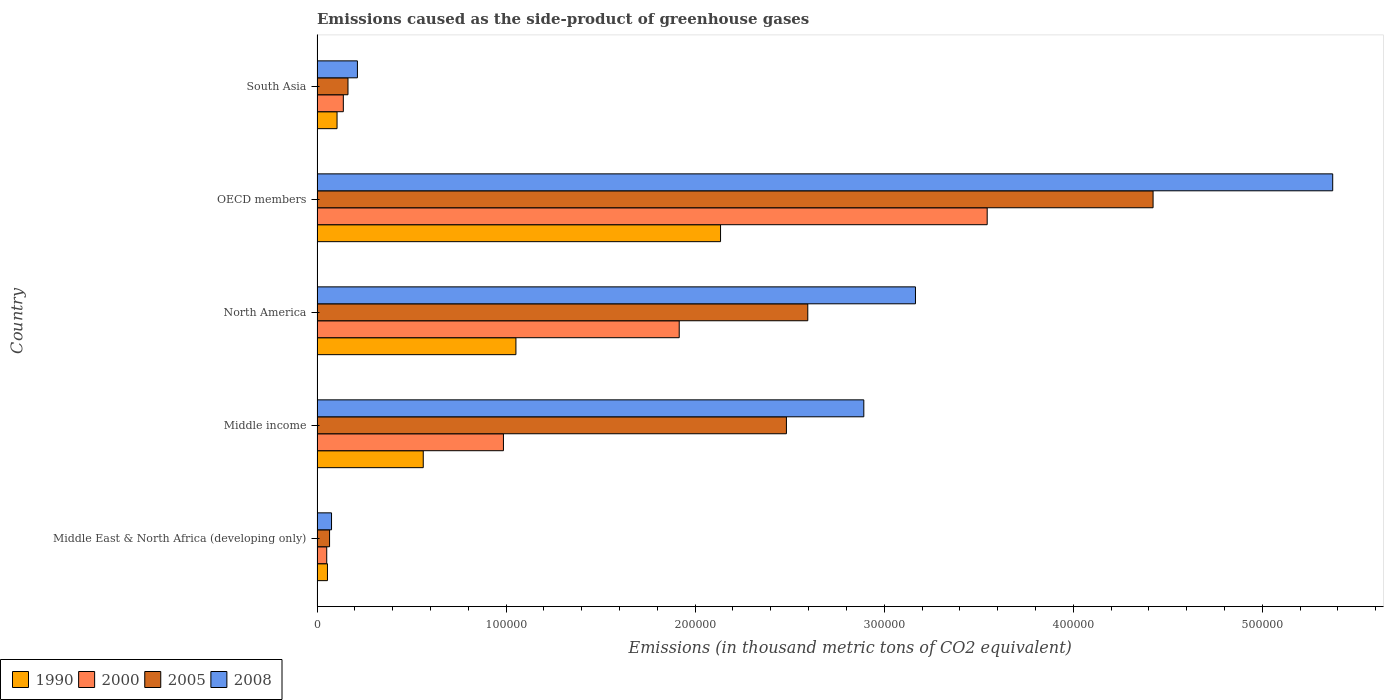How many groups of bars are there?
Your response must be concise. 5. Are the number of bars per tick equal to the number of legend labels?
Offer a very short reply. Yes. How many bars are there on the 1st tick from the top?
Provide a short and direct response. 4. In how many cases, is the number of bars for a given country not equal to the number of legend labels?
Keep it short and to the point. 0. What is the emissions caused as the side-product of greenhouse gases in 1990 in OECD members?
Provide a short and direct response. 2.13e+05. Across all countries, what is the maximum emissions caused as the side-product of greenhouse gases in 2005?
Your answer should be compact. 4.42e+05. Across all countries, what is the minimum emissions caused as the side-product of greenhouse gases in 2000?
Your answer should be compact. 5124.9. In which country was the emissions caused as the side-product of greenhouse gases in 2008 maximum?
Give a very brief answer. OECD members. In which country was the emissions caused as the side-product of greenhouse gases in 2008 minimum?
Ensure brevity in your answer.  Middle East & North Africa (developing only). What is the total emissions caused as the side-product of greenhouse gases in 2000 in the graph?
Provide a succinct answer. 6.64e+05. What is the difference between the emissions caused as the side-product of greenhouse gases in 2005 in OECD members and that in South Asia?
Make the answer very short. 4.26e+05. What is the difference between the emissions caused as the side-product of greenhouse gases in 2000 in OECD members and the emissions caused as the side-product of greenhouse gases in 2005 in Middle income?
Your answer should be very brief. 1.06e+05. What is the average emissions caused as the side-product of greenhouse gases in 2008 per country?
Provide a short and direct response. 2.34e+05. What is the difference between the emissions caused as the side-product of greenhouse gases in 1990 and emissions caused as the side-product of greenhouse gases in 2005 in Middle income?
Your answer should be compact. -1.92e+05. What is the ratio of the emissions caused as the side-product of greenhouse gases in 2005 in Middle East & North Africa (developing only) to that in Middle income?
Your answer should be very brief. 0.03. Is the difference between the emissions caused as the side-product of greenhouse gases in 1990 in Middle East & North Africa (developing only) and South Asia greater than the difference between the emissions caused as the side-product of greenhouse gases in 2005 in Middle East & North Africa (developing only) and South Asia?
Make the answer very short. Yes. What is the difference between the highest and the second highest emissions caused as the side-product of greenhouse gases in 2008?
Offer a very short reply. 2.21e+05. What is the difference between the highest and the lowest emissions caused as the side-product of greenhouse gases in 2000?
Provide a short and direct response. 3.49e+05. Is it the case that in every country, the sum of the emissions caused as the side-product of greenhouse gases in 2005 and emissions caused as the side-product of greenhouse gases in 2008 is greater than the sum of emissions caused as the side-product of greenhouse gases in 1990 and emissions caused as the side-product of greenhouse gases in 2000?
Your response must be concise. No. What does the 3rd bar from the top in South Asia represents?
Give a very brief answer. 2000. How many bars are there?
Provide a short and direct response. 20. How many countries are there in the graph?
Provide a succinct answer. 5. What is the difference between two consecutive major ticks on the X-axis?
Your response must be concise. 1.00e+05. Are the values on the major ticks of X-axis written in scientific E-notation?
Offer a very short reply. No. Does the graph contain any zero values?
Give a very brief answer. No. Does the graph contain grids?
Your answer should be very brief. No. How are the legend labels stacked?
Keep it short and to the point. Horizontal. What is the title of the graph?
Your answer should be very brief. Emissions caused as the side-product of greenhouse gases. Does "1971" appear as one of the legend labels in the graph?
Your answer should be compact. No. What is the label or title of the X-axis?
Give a very brief answer. Emissions (in thousand metric tons of CO2 equivalent). What is the Emissions (in thousand metric tons of CO2 equivalent) in 1990 in Middle East & North Africa (developing only)?
Ensure brevity in your answer.  5502.6. What is the Emissions (in thousand metric tons of CO2 equivalent) in 2000 in Middle East & North Africa (developing only)?
Ensure brevity in your answer.  5124.9. What is the Emissions (in thousand metric tons of CO2 equivalent) in 2005 in Middle East & North Africa (developing only)?
Keep it short and to the point. 6617.8. What is the Emissions (in thousand metric tons of CO2 equivalent) in 2008 in Middle East & North Africa (developing only)?
Your answer should be very brief. 7657.2. What is the Emissions (in thousand metric tons of CO2 equivalent) of 1990 in Middle income?
Give a very brief answer. 5.62e+04. What is the Emissions (in thousand metric tons of CO2 equivalent) in 2000 in Middle income?
Provide a succinct answer. 9.86e+04. What is the Emissions (in thousand metric tons of CO2 equivalent) of 2005 in Middle income?
Make the answer very short. 2.48e+05. What is the Emissions (in thousand metric tons of CO2 equivalent) in 2008 in Middle income?
Give a very brief answer. 2.89e+05. What is the Emissions (in thousand metric tons of CO2 equivalent) in 1990 in North America?
Your answer should be very brief. 1.05e+05. What is the Emissions (in thousand metric tons of CO2 equivalent) of 2000 in North America?
Your response must be concise. 1.92e+05. What is the Emissions (in thousand metric tons of CO2 equivalent) of 2005 in North America?
Offer a very short reply. 2.60e+05. What is the Emissions (in thousand metric tons of CO2 equivalent) in 2008 in North America?
Provide a succinct answer. 3.17e+05. What is the Emissions (in thousand metric tons of CO2 equivalent) in 1990 in OECD members?
Offer a very short reply. 2.13e+05. What is the Emissions (in thousand metric tons of CO2 equivalent) of 2000 in OECD members?
Your answer should be compact. 3.54e+05. What is the Emissions (in thousand metric tons of CO2 equivalent) in 2005 in OECD members?
Ensure brevity in your answer.  4.42e+05. What is the Emissions (in thousand metric tons of CO2 equivalent) of 2008 in OECD members?
Provide a succinct answer. 5.37e+05. What is the Emissions (in thousand metric tons of CO2 equivalent) of 1990 in South Asia?
Your answer should be compact. 1.06e+04. What is the Emissions (in thousand metric tons of CO2 equivalent) in 2000 in South Asia?
Provide a short and direct response. 1.39e+04. What is the Emissions (in thousand metric tons of CO2 equivalent) in 2005 in South Asia?
Offer a terse response. 1.64e+04. What is the Emissions (in thousand metric tons of CO2 equivalent) in 2008 in South Asia?
Give a very brief answer. 2.14e+04. Across all countries, what is the maximum Emissions (in thousand metric tons of CO2 equivalent) of 1990?
Offer a terse response. 2.13e+05. Across all countries, what is the maximum Emissions (in thousand metric tons of CO2 equivalent) of 2000?
Offer a terse response. 3.54e+05. Across all countries, what is the maximum Emissions (in thousand metric tons of CO2 equivalent) of 2005?
Provide a succinct answer. 4.42e+05. Across all countries, what is the maximum Emissions (in thousand metric tons of CO2 equivalent) of 2008?
Give a very brief answer. 5.37e+05. Across all countries, what is the minimum Emissions (in thousand metric tons of CO2 equivalent) in 1990?
Your response must be concise. 5502.6. Across all countries, what is the minimum Emissions (in thousand metric tons of CO2 equivalent) of 2000?
Give a very brief answer. 5124.9. Across all countries, what is the minimum Emissions (in thousand metric tons of CO2 equivalent) of 2005?
Offer a very short reply. 6617.8. Across all countries, what is the minimum Emissions (in thousand metric tons of CO2 equivalent) of 2008?
Your response must be concise. 7657.2. What is the total Emissions (in thousand metric tons of CO2 equivalent) in 1990 in the graph?
Provide a short and direct response. 3.91e+05. What is the total Emissions (in thousand metric tons of CO2 equivalent) of 2000 in the graph?
Ensure brevity in your answer.  6.64e+05. What is the total Emissions (in thousand metric tons of CO2 equivalent) in 2005 in the graph?
Provide a succinct answer. 9.73e+05. What is the total Emissions (in thousand metric tons of CO2 equivalent) in 2008 in the graph?
Ensure brevity in your answer.  1.17e+06. What is the difference between the Emissions (in thousand metric tons of CO2 equivalent) in 1990 in Middle East & North Africa (developing only) and that in Middle income?
Give a very brief answer. -5.07e+04. What is the difference between the Emissions (in thousand metric tons of CO2 equivalent) in 2000 in Middle East & North Africa (developing only) and that in Middle income?
Your response must be concise. -9.35e+04. What is the difference between the Emissions (in thousand metric tons of CO2 equivalent) in 2005 in Middle East & North Africa (developing only) and that in Middle income?
Provide a succinct answer. -2.42e+05. What is the difference between the Emissions (in thousand metric tons of CO2 equivalent) of 2008 in Middle East & North Africa (developing only) and that in Middle income?
Provide a succinct answer. -2.82e+05. What is the difference between the Emissions (in thousand metric tons of CO2 equivalent) in 1990 in Middle East & North Africa (developing only) and that in North America?
Provide a short and direct response. -9.97e+04. What is the difference between the Emissions (in thousand metric tons of CO2 equivalent) of 2000 in Middle East & North Africa (developing only) and that in North America?
Make the answer very short. -1.86e+05. What is the difference between the Emissions (in thousand metric tons of CO2 equivalent) in 2005 in Middle East & North Africa (developing only) and that in North America?
Ensure brevity in your answer.  -2.53e+05. What is the difference between the Emissions (in thousand metric tons of CO2 equivalent) of 2008 in Middle East & North Africa (developing only) and that in North America?
Provide a short and direct response. -3.09e+05. What is the difference between the Emissions (in thousand metric tons of CO2 equivalent) of 1990 in Middle East & North Africa (developing only) and that in OECD members?
Offer a very short reply. -2.08e+05. What is the difference between the Emissions (in thousand metric tons of CO2 equivalent) in 2000 in Middle East & North Africa (developing only) and that in OECD members?
Keep it short and to the point. -3.49e+05. What is the difference between the Emissions (in thousand metric tons of CO2 equivalent) of 2005 in Middle East & North Africa (developing only) and that in OECD members?
Your response must be concise. -4.36e+05. What is the difference between the Emissions (in thousand metric tons of CO2 equivalent) of 2008 in Middle East & North Africa (developing only) and that in OECD members?
Keep it short and to the point. -5.30e+05. What is the difference between the Emissions (in thousand metric tons of CO2 equivalent) in 1990 in Middle East & North Africa (developing only) and that in South Asia?
Ensure brevity in your answer.  -5070. What is the difference between the Emissions (in thousand metric tons of CO2 equivalent) of 2000 in Middle East & North Africa (developing only) and that in South Asia?
Offer a very short reply. -8773. What is the difference between the Emissions (in thousand metric tons of CO2 equivalent) of 2005 in Middle East & North Africa (developing only) and that in South Asia?
Make the answer very short. -9741.3. What is the difference between the Emissions (in thousand metric tons of CO2 equivalent) of 2008 in Middle East & North Africa (developing only) and that in South Asia?
Give a very brief answer. -1.37e+04. What is the difference between the Emissions (in thousand metric tons of CO2 equivalent) of 1990 in Middle income and that in North America?
Provide a short and direct response. -4.90e+04. What is the difference between the Emissions (in thousand metric tons of CO2 equivalent) in 2000 in Middle income and that in North America?
Give a very brief answer. -9.30e+04. What is the difference between the Emissions (in thousand metric tons of CO2 equivalent) in 2005 in Middle income and that in North America?
Ensure brevity in your answer.  -1.13e+04. What is the difference between the Emissions (in thousand metric tons of CO2 equivalent) of 2008 in Middle income and that in North America?
Provide a succinct answer. -2.73e+04. What is the difference between the Emissions (in thousand metric tons of CO2 equivalent) of 1990 in Middle income and that in OECD members?
Your response must be concise. -1.57e+05. What is the difference between the Emissions (in thousand metric tons of CO2 equivalent) of 2000 in Middle income and that in OECD members?
Your answer should be compact. -2.56e+05. What is the difference between the Emissions (in thousand metric tons of CO2 equivalent) in 2005 in Middle income and that in OECD members?
Offer a terse response. -1.94e+05. What is the difference between the Emissions (in thousand metric tons of CO2 equivalent) of 2008 in Middle income and that in OECD members?
Your answer should be very brief. -2.48e+05. What is the difference between the Emissions (in thousand metric tons of CO2 equivalent) of 1990 in Middle income and that in South Asia?
Offer a terse response. 4.56e+04. What is the difference between the Emissions (in thousand metric tons of CO2 equivalent) of 2000 in Middle income and that in South Asia?
Make the answer very short. 8.47e+04. What is the difference between the Emissions (in thousand metric tons of CO2 equivalent) in 2005 in Middle income and that in South Asia?
Make the answer very short. 2.32e+05. What is the difference between the Emissions (in thousand metric tons of CO2 equivalent) of 2008 in Middle income and that in South Asia?
Offer a terse response. 2.68e+05. What is the difference between the Emissions (in thousand metric tons of CO2 equivalent) of 1990 in North America and that in OECD members?
Ensure brevity in your answer.  -1.08e+05. What is the difference between the Emissions (in thousand metric tons of CO2 equivalent) in 2000 in North America and that in OECD members?
Ensure brevity in your answer.  -1.63e+05. What is the difference between the Emissions (in thousand metric tons of CO2 equivalent) of 2005 in North America and that in OECD members?
Offer a terse response. -1.83e+05. What is the difference between the Emissions (in thousand metric tons of CO2 equivalent) of 2008 in North America and that in OECD members?
Ensure brevity in your answer.  -2.21e+05. What is the difference between the Emissions (in thousand metric tons of CO2 equivalent) in 1990 in North America and that in South Asia?
Offer a terse response. 9.46e+04. What is the difference between the Emissions (in thousand metric tons of CO2 equivalent) in 2000 in North America and that in South Asia?
Make the answer very short. 1.78e+05. What is the difference between the Emissions (in thousand metric tons of CO2 equivalent) of 2005 in North America and that in South Asia?
Offer a terse response. 2.43e+05. What is the difference between the Emissions (in thousand metric tons of CO2 equivalent) of 2008 in North America and that in South Asia?
Your answer should be compact. 2.95e+05. What is the difference between the Emissions (in thousand metric tons of CO2 equivalent) of 1990 in OECD members and that in South Asia?
Your answer should be compact. 2.03e+05. What is the difference between the Emissions (in thousand metric tons of CO2 equivalent) of 2000 in OECD members and that in South Asia?
Keep it short and to the point. 3.41e+05. What is the difference between the Emissions (in thousand metric tons of CO2 equivalent) in 2005 in OECD members and that in South Asia?
Give a very brief answer. 4.26e+05. What is the difference between the Emissions (in thousand metric tons of CO2 equivalent) in 2008 in OECD members and that in South Asia?
Offer a very short reply. 5.16e+05. What is the difference between the Emissions (in thousand metric tons of CO2 equivalent) of 1990 in Middle East & North Africa (developing only) and the Emissions (in thousand metric tons of CO2 equivalent) of 2000 in Middle income?
Give a very brief answer. -9.31e+04. What is the difference between the Emissions (in thousand metric tons of CO2 equivalent) of 1990 in Middle East & North Africa (developing only) and the Emissions (in thousand metric tons of CO2 equivalent) of 2005 in Middle income?
Your answer should be very brief. -2.43e+05. What is the difference between the Emissions (in thousand metric tons of CO2 equivalent) in 1990 in Middle East & North Africa (developing only) and the Emissions (in thousand metric tons of CO2 equivalent) in 2008 in Middle income?
Ensure brevity in your answer.  -2.84e+05. What is the difference between the Emissions (in thousand metric tons of CO2 equivalent) of 2000 in Middle East & North Africa (developing only) and the Emissions (in thousand metric tons of CO2 equivalent) of 2005 in Middle income?
Ensure brevity in your answer.  -2.43e+05. What is the difference between the Emissions (in thousand metric tons of CO2 equivalent) in 2000 in Middle East & North Africa (developing only) and the Emissions (in thousand metric tons of CO2 equivalent) in 2008 in Middle income?
Make the answer very short. -2.84e+05. What is the difference between the Emissions (in thousand metric tons of CO2 equivalent) of 2005 in Middle East & North Africa (developing only) and the Emissions (in thousand metric tons of CO2 equivalent) of 2008 in Middle income?
Your answer should be very brief. -2.83e+05. What is the difference between the Emissions (in thousand metric tons of CO2 equivalent) of 1990 in Middle East & North Africa (developing only) and the Emissions (in thousand metric tons of CO2 equivalent) of 2000 in North America?
Give a very brief answer. -1.86e+05. What is the difference between the Emissions (in thousand metric tons of CO2 equivalent) of 1990 in Middle East & North Africa (developing only) and the Emissions (in thousand metric tons of CO2 equivalent) of 2005 in North America?
Ensure brevity in your answer.  -2.54e+05. What is the difference between the Emissions (in thousand metric tons of CO2 equivalent) in 1990 in Middle East & North Africa (developing only) and the Emissions (in thousand metric tons of CO2 equivalent) in 2008 in North America?
Offer a terse response. -3.11e+05. What is the difference between the Emissions (in thousand metric tons of CO2 equivalent) in 2000 in Middle East & North Africa (developing only) and the Emissions (in thousand metric tons of CO2 equivalent) in 2005 in North America?
Your response must be concise. -2.54e+05. What is the difference between the Emissions (in thousand metric tons of CO2 equivalent) in 2000 in Middle East & North Africa (developing only) and the Emissions (in thousand metric tons of CO2 equivalent) in 2008 in North America?
Offer a terse response. -3.11e+05. What is the difference between the Emissions (in thousand metric tons of CO2 equivalent) of 2005 in Middle East & North Africa (developing only) and the Emissions (in thousand metric tons of CO2 equivalent) of 2008 in North America?
Your answer should be compact. -3.10e+05. What is the difference between the Emissions (in thousand metric tons of CO2 equivalent) of 1990 in Middle East & North Africa (developing only) and the Emissions (in thousand metric tons of CO2 equivalent) of 2000 in OECD members?
Your answer should be very brief. -3.49e+05. What is the difference between the Emissions (in thousand metric tons of CO2 equivalent) in 1990 in Middle East & North Africa (developing only) and the Emissions (in thousand metric tons of CO2 equivalent) in 2005 in OECD members?
Your answer should be compact. -4.37e+05. What is the difference between the Emissions (in thousand metric tons of CO2 equivalent) in 1990 in Middle East & North Africa (developing only) and the Emissions (in thousand metric tons of CO2 equivalent) in 2008 in OECD members?
Your answer should be compact. -5.32e+05. What is the difference between the Emissions (in thousand metric tons of CO2 equivalent) of 2000 in Middle East & North Africa (developing only) and the Emissions (in thousand metric tons of CO2 equivalent) of 2005 in OECD members?
Provide a succinct answer. -4.37e+05. What is the difference between the Emissions (in thousand metric tons of CO2 equivalent) of 2000 in Middle East & North Africa (developing only) and the Emissions (in thousand metric tons of CO2 equivalent) of 2008 in OECD members?
Provide a succinct answer. -5.32e+05. What is the difference between the Emissions (in thousand metric tons of CO2 equivalent) of 2005 in Middle East & North Africa (developing only) and the Emissions (in thousand metric tons of CO2 equivalent) of 2008 in OECD members?
Provide a succinct answer. -5.31e+05. What is the difference between the Emissions (in thousand metric tons of CO2 equivalent) of 1990 in Middle East & North Africa (developing only) and the Emissions (in thousand metric tons of CO2 equivalent) of 2000 in South Asia?
Provide a succinct answer. -8395.3. What is the difference between the Emissions (in thousand metric tons of CO2 equivalent) of 1990 in Middle East & North Africa (developing only) and the Emissions (in thousand metric tons of CO2 equivalent) of 2005 in South Asia?
Make the answer very short. -1.09e+04. What is the difference between the Emissions (in thousand metric tons of CO2 equivalent) of 1990 in Middle East & North Africa (developing only) and the Emissions (in thousand metric tons of CO2 equivalent) of 2008 in South Asia?
Provide a succinct answer. -1.59e+04. What is the difference between the Emissions (in thousand metric tons of CO2 equivalent) in 2000 in Middle East & North Africa (developing only) and the Emissions (in thousand metric tons of CO2 equivalent) in 2005 in South Asia?
Provide a short and direct response. -1.12e+04. What is the difference between the Emissions (in thousand metric tons of CO2 equivalent) in 2000 in Middle East & North Africa (developing only) and the Emissions (in thousand metric tons of CO2 equivalent) in 2008 in South Asia?
Your response must be concise. -1.62e+04. What is the difference between the Emissions (in thousand metric tons of CO2 equivalent) in 2005 in Middle East & North Africa (developing only) and the Emissions (in thousand metric tons of CO2 equivalent) in 2008 in South Asia?
Your answer should be very brief. -1.47e+04. What is the difference between the Emissions (in thousand metric tons of CO2 equivalent) in 1990 in Middle income and the Emissions (in thousand metric tons of CO2 equivalent) in 2000 in North America?
Give a very brief answer. -1.35e+05. What is the difference between the Emissions (in thousand metric tons of CO2 equivalent) of 1990 in Middle income and the Emissions (in thousand metric tons of CO2 equivalent) of 2005 in North America?
Provide a short and direct response. -2.03e+05. What is the difference between the Emissions (in thousand metric tons of CO2 equivalent) of 1990 in Middle income and the Emissions (in thousand metric tons of CO2 equivalent) of 2008 in North America?
Your response must be concise. -2.60e+05. What is the difference between the Emissions (in thousand metric tons of CO2 equivalent) in 2000 in Middle income and the Emissions (in thousand metric tons of CO2 equivalent) in 2005 in North America?
Provide a succinct answer. -1.61e+05. What is the difference between the Emissions (in thousand metric tons of CO2 equivalent) of 2000 in Middle income and the Emissions (in thousand metric tons of CO2 equivalent) of 2008 in North America?
Keep it short and to the point. -2.18e+05. What is the difference between the Emissions (in thousand metric tons of CO2 equivalent) in 2005 in Middle income and the Emissions (in thousand metric tons of CO2 equivalent) in 2008 in North America?
Provide a succinct answer. -6.83e+04. What is the difference between the Emissions (in thousand metric tons of CO2 equivalent) in 1990 in Middle income and the Emissions (in thousand metric tons of CO2 equivalent) in 2000 in OECD members?
Offer a very short reply. -2.98e+05. What is the difference between the Emissions (in thousand metric tons of CO2 equivalent) in 1990 in Middle income and the Emissions (in thousand metric tons of CO2 equivalent) in 2005 in OECD members?
Make the answer very short. -3.86e+05. What is the difference between the Emissions (in thousand metric tons of CO2 equivalent) of 1990 in Middle income and the Emissions (in thousand metric tons of CO2 equivalent) of 2008 in OECD members?
Provide a short and direct response. -4.81e+05. What is the difference between the Emissions (in thousand metric tons of CO2 equivalent) in 2000 in Middle income and the Emissions (in thousand metric tons of CO2 equivalent) in 2005 in OECD members?
Offer a very short reply. -3.44e+05. What is the difference between the Emissions (in thousand metric tons of CO2 equivalent) in 2000 in Middle income and the Emissions (in thousand metric tons of CO2 equivalent) in 2008 in OECD members?
Ensure brevity in your answer.  -4.39e+05. What is the difference between the Emissions (in thousand metric tons of CO2 equivalent) of 2005 in Middle income and the Emissions (in thousand metric tons of CO2 equivalent) of 2008 in OECD members?
Your answer should be compact. -2.89e+05. What is the difference between the Emissions (in thousand metric tons of CO2 equivalent) in 1990 in Middle income and the Emissions (in thousand metric tons of CO2 equivalent) in 2000 in South Asia?
Your response must be concise. 4.23e+04. What is the difference between the Emissions (in thousand metric tons of CO2 equivalent) in 1990 in Middle income and the Emissions (in thousand metric tons of CO2 equivalent) in 2005 in South Asia?
Keep it short and to the point. 3.98e+04. What is the difference between the Emissions (in thousand metric tons of CO2 equivalent) in 1990 in Middle income and the Emissions (in thousand metric tons of CO2 equivalent) in 2008 in South Asia?
Make the answer very short. 3.48e+04. What is the difference between the Emissions (in thousand metric tons of CO2 equivalent) in 2000 in Middle income and the Emissions (in thousand metric tons of CO2 equivalent) in 2005 in South Asia?
Your response must be concise. 8.22e+04. What is the difference between the Emissions (in thousand metric tons of CO2 equivalent) of 2000 in Middle income and the Emissions (in thousand metric tons of CO2 equivalent) of 2008 in South Asia?
Offer a terse response. 7.72e+04. What is the difference between the Emissions (in thousand metric tons of CO2 equivalent) of 2005 in Middle income and the Emissions (in thousand metric tons of CO2 equivalent) of 2008 in South Asia?
Provide a succinct answer. 2.27e+05. What is the difference between the Emissions (in thousand metric tons of CO2 equivalent) of 1990 in North America and the Emissions (in thousand metric tons of CO2 equivalent) of 2000 in OECD members?
Your answer should be compact. -2.49e+05. What is the difference between the Emissions (in thousand metric tons of CO2 equivalent) of 1990 in North America and the Emissions (in thousand metric tons of CO2 equivalent) of 2005 in OECD members?
Offer a terse response. -3.37e+05. What is the difference between the Emissions (in thousand metric tons of CO2 equivalent) of 1990 in North America and the Emissions (in thousand metric tons of CO2 equivalent) of 2008 in OECD members?
Give a very brief answer. -4.32e+05. What is the difference between the Emissions (in thousand metric tons of CO2 equivalent) of 2000 in North America and the Emissions (in thousand metric tons of CO2 equivalent) of 2005 in OECD members?
Make the answer very short. -2.51e+05. What is the difference between the Emissions (in thousand metric tons of CO2 equivalent) of 2000 in North America and the Emissions (in thousand metric tons of CO2 equivalent) of 2008 in OECD members?
Give a very brief answer. -3.46e+05. What is the difference between the Emissions (in thousand metric tons of CO2 equivalent) of 2005 in North America and the Emissions (in thousand metric tons of CO2 equivalent) of 2008 in OECD members?
Keep it short and to the point. -2.78e+05. What is the difference between the Emissions (in thousand metric tons of CO2 equivalent) in 1990 in North America and the Emissions (in thousand metric tons of CO2 equivalent) in 2000 in South Asia?
Provide a short and direct response. 9.13e+04. What is the difference between the Emissions (in thousand metric tons of CO2 equivalent) in 1990 in North America and the Emissions (in thousand metric tons of CO2 equivalent) in 2005 in South Asia?
Offer a terse response. 8.88e+04. What is the difference between the Emissions (in thousand metric tons of CO2 equivalent) of 1990 in North America and the Emissions (in thousand metric tons of CO2 equivalent) of 2008 in South Asia?
Your answer should be very brief. 8.38e+04. What is the difference between the Emissions (in thousand metric tons of CO2 equivalent) in 2000 in North America and the Emissions (in thousand metric tons of CO2 equivalent) in 2005 in South Asia?
Keep it short and to the point. 1.75e+05. What is the difference between the Emissions (in thousand metric tons of CO2 equivalent) in 2000 in North America and the Emissions (in thousand metric tons of CO2 equivalent) in 2008 in South Asia?
Your response must be concise. 1.70e+05. What is the difference between the Emissions (in thousand metric tons of CO2 equivalent) in 2005 in North America and the Emissions (in thousand metric tons of CO2 equivalent) in 2008 in South Asia?
Make the answer very short. 2.38e+05. What is the difference between the Emissions (in thousand metric tons of CO2 equivalent) in 1990 in OECD members and the Emissions (in thousand metric tons of CO2 equivalent) in 2000 in South Asia?
Give a very brief answer. 2.00e+05. What is the difference between the Emissions (in thousand metric tons of CO2 equivalent) of 1990 in OECD members and the Emissions (in thousand metric tons of CO2 equivalent) of 2005 in South Asia?
Your response must be concise. 1.97e+05. What is the difference between the Emissions (in thousand metric tons of CO2 equivalent) of 1990 in OECD members and the Emissions (in thousand metric tons of CO2 equivalent) of 2008 in South Asia?
Make the answer very short. 1.92e+05. What is the difference between the Emissions (in thousand metric tons of CO2 equivalent) of 2000 in OECD members and the Emissions (in thousand metric tons of CO2 equivalent) of 2005 in South Asia?
Your response must be concise. 3.38e+05. What is the difference between the Emissions (in thousand metric tons of CO2 equivalent) in 2000 in OECD members and the Emissions (in thousand metric tons of CO2 equivalent) in 2008 in South Asia?
Give a very brief answer. 3.33e+05. What is the difference between the Emissions (in thousand metric tons of CO2 equivalent) of 2005 in OECD members and the Emissions (in thousand metric tons of CO2 equivalent) of 2008 in South Asia?
Offer a terse response. 4.21e+05. What is the average Emissions (in thousand metric tons of CO2 equivalent) of 1990 per country?
Provide a short and direct response. 7.82e+04. What is the average Emissions (in thousand metric tons of CO2 equivalent) in 2000 per country?
Provide a succinct answer. 1.33e+05. What is the average Emissions (in thousand metric tons of CO2 equivalent) in 2005 per country?
Make the answer very short. 1.95e+05. What is the average Emissions (in thousand metric tons of CO2 equivalent) in 2008 per country?
Your answer should be very brief. 2.34e+05. What is the difference between the Emissions (in thousand metric tons of CO2 equivalent) of 1990 and Emissions (in thousand metric tons of CO2 equivalent) of 2000 in Middle East & North Africa (developing only)?
Ensure brevity in your answer.  377.7. What is the difference between the Emissions (in thousand metric tons of CO2 equivalent) of 1990 and Emissions (in thousand metric tons of CO2 equivalent) of 2005 in Middle East & North Africa (developing only)?
Provide a short and direct response. -1115.2. What is the difference between the Emissions (in thousand metric tons of CO2 equivalent) in 1990 and Emissions (in thousand metric tons of CO2 equivalent) in 2008 in Middle East & North Africa (developing only)?
Offer a terse response. -2154.6. What is the difference between the Emissions (in thousand metric tons of CO2 equivalent) in 2000 and Emissions (in thousand metric tons of CO2 equivalent) in 2005 in Middle East & North Africa (developing only)?
Your answer should be compact. -1492.9. What is the difference between the Emissions (in thousand metric tons of CO2 equivalent) in 2000 and Emissions (in thousand metric tons of CO2 equivalent) in 2008 in Middle East & North Africa (developing only)?
Offer a very short reply. -2532.3. What is the difference between the Emissions (in thousand metric tons of CO2 equivalent) in 2005 and Emissions (in thousand metric tons of CO2 equivalent) in 2008 in Middle East & North Africa (developing only)?
Provide a short and direct response. -1039.4. What is the difference between the Emissions (in thousand metric tons of CO2 equivalent) in 1990 and Emissions (in thousand metric tons of CO2 equivalent) in 2000 in Middle income?
Offer a terse response. -4.24e+04. What is the difference between the Emissions (in thousand metric tons of CO2 equivalent) in 1990 and Emissions (in thousand metric tons of CO2 equivalent) in 2005 in Middle income?
Offer a very short reply. -1.92e+05. What is the difference between the Emissions (in thousand metric tons of CO2 equivalent) in 1990 and Emissions (in thousand metric tons of CO2 equivalent) in 2008 in Middle income?
Keep it short and to the point. -2.33e+05. What is the difference between the Emissions (in thousand metric tons of CO2 equivalent) in 2000 and Emissions (in thousand metric tons of CO2 equivalent) in 2005 in Middle income?
Give a very brief answer. -1.50e+05. What is the difference between the Emissions (in thousand metric tons of CO2 equivalent) of 2000 and Emissions (in thousand metric tons of CO2 equivalent) of 2008 in Middle income?
Make the answer very short. -1.91e+05. What is the difference between the Emissions (in thousand metric tons of CO2 equivalent) in 2005 and Emissions (in thousand metric tons of CO2 equivalent) in 2008 in Middle income?
Ensure brevity in your answer.  -4.09e+04. What is the difference between the Emissions (in thousand metric tons of CO2 equivalent) of 1990 and Emissions (in thousand metric tons of CO2 equivalent) of 2000 in North America?
Your answer should be compact. -8.64e+04. What is the difference between the Emissions (in thousand metric tons of CO2 equivalent) in 1990 and Emissions (in thousand metric tons of CO2 equivalent) in 2005 in North America?
Provide a succinct answer. -1.54e+05. What is the difference between the Emissions (in thousand metric tons of CO2 equivalent) in 1990 and Emissions (in thousand metric tons of CO2 equivalent) in 2008 in North America?
Ensure brevity in your answer.  -2.11e+05. What is the difference between the Emissions (in thousand metric tons of CO2 equivalent) of 2000 and Emissions (in thousand metric tons of CO2 equivalent) of 2005 in North America?
Offer a very short reply. -6.80e+04. What is the difference between the Emissions (in thousand metric tons of CO2 equivalent) in 2000 and Emissions (in thousand metric tons of CO2 equivalent) in 2008 in North America?
Ensure brevity in your answer.  -1.25e+05. What is the difference between the Emissions (in thousand metric tons of CO2 equivalent) of 2005 and Emissions (in thousand metric tons of CO2 equivalent) of 2008 in North America?
Offer a terse response. -5.70e+04. What is the difference between the Emissions (in thousand metric tons of CO2 equivalent) of 1990 and Emissions (in thousand metric tons of CO2 equivalent) of 2000 in OECD members?
Ensure brevity in your answer.  -1.41e+05. What is the difference between the Emissions (in thousand metric tons of CO2 equivalent) in 1990 and Emissions (in thousand metric tons of CO2 equivalent) in 2005 in OECD members?
Make the answer very short. -2.29e+05. What is the difference between the Emissions (in thousand metric tons of CO2 equivalent) of 1990 and Emissions (in thousand metric tons of CO2 equivalent) of 2008 in OECD members?
Your response must be concise. -3.24e+05. What is the difference between the Emissions (in thousand metric tons of CO2 equivalent) in 2000 and Emissions (in thousand metric tons of CO2 equivalent) in 2005 in OECD members?
Offer a very short reply. -8.78e+04. What is the difference between the Emissions (in thousand metric tons of CO2 equivalent) of 2000 and Emissions (in thousand metric tons of CO2 equivalent) of 2008 in OECD members?
Make the answer very short. -1.83e+05. What is the difference between the Emissions (in thousand metric tons of CO2 equivalent) in 2005 and Emissions (in thousand metric tons of CO2 equivalent) in 2008 in OECD members?
Your answer should be compact. -9.50e+04. What is the difference between the Emissions (in thousand metric tons of CO2 equivalent) in 1990 and Emissions (in thousand metric tons of CO2 equivalent) in 2000 in South Asia?
Make the answer very short. -3325.3. What is the difference between the Emissions (in thousand metric tons of CO2 equivalent) in 1990 and Emissions (in thousand metric tons of CO2 equivalent) in 2005 in South Asia?
Your answer should be compact. -5786.5. What is the difference between the Emissions (in thousand metric tons of CO2 equivalent) of 1990 and Emissions (in thousand metric tons of CO2 equivalent) of 2008 in South Asia?
Give a very brief answer. -1.08e+04. What is the difference between the Emissions (in thousand metric tons of CO2 equivalent) in 2000 and Emissions (in thousand metric tons of CO2 equivalent) in 2005 in South Asia?
Give a very brief answer. -2461.2. What is the difference between the Emissions (in thousand metric tons of CO2 equivalent) of 2000 and Emissions (in thousand metric tons of CO2 equivalent) of 2008 in South Asia?
Your answer should be very brief. -7460.6. What is the difference between the Emissions (in thousand metric tons of CO2 equivalent) of 2005 and Emissions (in thousand metric tons of CO2 equivalent) of 2008 in South Asia?
Make the answer very short. -4999.4. What is the ratio of the Emissions (in thousand metric tons of CO2 equivalent) in 1990 in Middle East & North Africa (developing only) to that in Middle income?
Provide a succinct answer. 0.1. What is the ratio of the Emissions (in thousand metric tons of CO2 equivalent) in 2000 in Middle East & North Africa (developing only) to that in Middle income?
Ensure brevity in your answer.  0.05. What is the ratio of the Emissions (in thousand metric tons of CO2 equivalent) in 2005 in Middle East & North Africa (developing only) to that in Middle income?
Provide a short and direct response. 0.03. What is the ratio of the Emissions (in thousand metric tons of CO2 equivalent) in 2008 in Middle East & North Africa (developing only) to that in Middle income?
Make the answer very short. 0.03. What is the ratio of the Emissions (in thousand metric tons of CO2 equivalent) in 1990 in Middle East & North Africa (developing only) to that in North America?
Offer a very short reply. 0.05. What is the ratio of the Emissions (in thousand metric tons of CO2 equivalent) of 2000 in Middle East & North Africa (developing only) to that in North America?
Ensure brevity in your answer.  0.03. What is the ratio of the Emissions (in thousand metric tons of CO2 equivalent) of 2005 in Middle East & North Africa (developing only) to that in North America?
Offer a very short reply. 0.03. What is the ratio of the Emissions (in thousand metric tons of CO2 equivalent) of 2008 in Middle East & North Africa (developing only) to that in North America?
Your answer should be very brief. 0.02. What is the ratio of the Emissions (in thousand metric tons of CO2 equivalent) of 1990 in Middle East & North Africa (developing only) to that in OECD members?
Ensure brevity in your answer.  0.03. What is the ratio of the Emissions (in thousand metric tons of CO2 equivalent) of 2000 in Middle East & North Africa (developing only) to that in OECD members?
Keep it short and to the point. 0.01. What is the ratio of the Emissions (in thousand metric tons of CO2 equivalent) of 2005 in Middle East & North Africa (developing only) to that in OECD members?
Give a very brief answer. 0.01. What is the ratio of the Emissions (in thousand metric tons of CO2 equivalent) of 2008 in Middle East & North Africa (developing only) to that in OECD members?
Offer a terse response. 0.01. What is the ratio of the Emissions (in thousand metric tons of CO2 equivalent) in 1990 in Middle East & North Africa (developing only) to that in South Asia?
Your answer should be compact. 0.52. What is the ratio of the Emissions (in thousand metric tons of CO2 equivalent) of 2000 in Middle East & North Africa (developing only) to that in South Asia?
Offer a very short reply. 0.37. What is the ratio of the Emissions (in thousand metric tons of CO2 equivalent) in 2005 in Middle East & North Africa (developing only) to that in South Asia?
Provide a short and direct response. 0.4. What is the ratio of the Emissions (in thousand metric tons of CO2 equivalent) of 2008 in Middle East & North Africa (developing only) to that in South Asia?
Offer a terse response. 0.36. What is the ratio of the Emissions (in thousand metric tons of CO2 equivalent) in 1990 in Middle income to that in North America?
Provide a succinct answer. 0.53. What is the ratio of the Emissions (in thousand metric tons of CO2 equivalent) in 2000 in Middle income to that in North America?
Ensure brevity in your answer.  0.51. What is the ratio of the Emissions (in thousand metric tons of CO2 equivalent) in 2005 in Middle income to that in North America?
Ensure brevity in your answer.  0.96. What is the ratio of the Emissions (in thousand metric tons of CO2 equivalent) of 2008 in Middle income to that in North America?
Offer a very short reply. 0.91. What is the ratio of the Emissions (in thousand metric tons of CO2 equivalent) in 1990 in Middle income to that in OECD members?
Offer a very short reply. 0.26. What is the ratio of the Emissions (in thousand metric tons of CO2 equivalent) of 2000 in Middle income to that in OECD members?
Offer a very short reply. 0.28. What is the ratio of the Emissions (in thousand metric tons of CO2 equivalent) in 2005 in Middle income to that in OECD members?
Provide a succinct answer. 0.56. What is the ratio of the Emissions (in thousand metric tons of CO2 equivalent) in 2008 in Middle income to that in OECD members?
Ensure brevity in your answer.  0.54. What is the ratio of the Emissions (in thousand metric tons of CO2 equivalent) in 1990 in Middle income to that in South Asia?
Make the answer very short. 5.31. What is the ratio of the Emissions (in thousand metric tons of CO2 equivalent) in 2000 in Middle income to that in South Asia?
Provide a succinct answer. 7.09. What is the ratio of the Emissions (in thousand metric tons of CO2 equivalent) in 2005 in Middle income to that in South Asia?
Keep it short and to the point. 15.18. What is the ratio of the Emissions (in thousand metric tons of CO2 equivalent) of 2008 in Middle income to that in South Asia?
Your answer should be very brief. 13.54. What is the ratio of the Emissions (in thousand metric tons of CO2 equivalent) of 1990 in North America to that in OECD members?
Offer a very short reply. 0.49. What is the ratio of the Emissions (in thousand metric tons of CO2 equivalent) of 2000 in North America to that in OECD members?
Keep it short and to the point. 0.54. What is the ratio of the Emissions (in thousand metric tons of CO2 equivalent) of 2005 in North America to that in OECD members?
Your answer should be very brief. 0.59. What is the ratio of the Emissions (in thousand metric tons of CO2 equivalent) of 2008 in North America to that in OECD members?
Keep it short and to the point. 0.59. What is the ratio of the Emissions (in thousand metric tons of CO2 equivalent) in 1990 in North America to that in South Asia?
Offer a terse response. 9.95. What is the ratio of the Emissions (in thousand metric tons of CO2 equivalent) of 2000 in North America to that in South Asia?
Provide a succinct answer. 13.79. What is the ratio of the Emissions (in thousand metric tons of CO2 equivalent) of 2005 in North America to that in South Asia?
Make the answer very short. 15.87. What is the ratio of the Emissions (in thousand metric tons of CO2 equivalent) in 2008 in North America to that in South Asia?
Ensure brevity in your answer.  14.82. What is the ratio of the Emissions (in thousand metric tons of CO2 equivalent) in 1990 in OECD members to that in South Asia?
Offer a terse response. 20.19. What is the ratio of the Emissions (in thousand metric tons of CO2 equivalent) in 2000 in OECD members to that in South Asia?
Provide a succinct answer. 25.51. What is the ratio of the Emissions (in thousand metric tons of CO2 equivalent) in 2005 in OECD members to that in South Asia?
Your answer should be compact. 27.03. What is the ratio of the Emissions (in thousand metric tons of CO2 equivalent) in 2008 in OECD members to that in South Asia?
Keep it short and to the point. 25.15. What is the difference between the highest and the second highest Emissions (in thousand metric tons of CO2 equivalent) in 1990?
Make the answer very short. 1.08e+05. What is the difference between the highest and the second highest Emissions (in thousand metric tons of CO2 equivalent) of 2000?
Make the answer very short. 1.63e+05. What is the difference between the highest and the second highest Emissions (in thousand metric tons of CO2 equivalent) of 2005?
Offer a terse response. 1.83e+05. What is the difference between the highest and the second highest Emissions (in thousand metric tons of CO2 equivalent) of 2008?
Your answer should be very brief. 2.21e+05. What is the difference between the highest and the lowest Emissions (in thousand metric tons of CO2 equivalent) in 1990?
Offer a very short reply. 2.08e+05. What is the difference between the highest and the lowest Emissions (in thousand metric tons of CO2 equivalent) in 2000?
Your answer should be very brief. 3.49e+05. What is the difference between the highest and the lowest Emissions (in thousand metric tons of CO2 equivalent) of 2005?
Offer a very short reply. 4.36e+05. What is the difference between the highest and the lowest Emissions (in thousand metric tons of CO2 equivalent) in 2008?
Provide a succinct answer. 5.30e+05. 